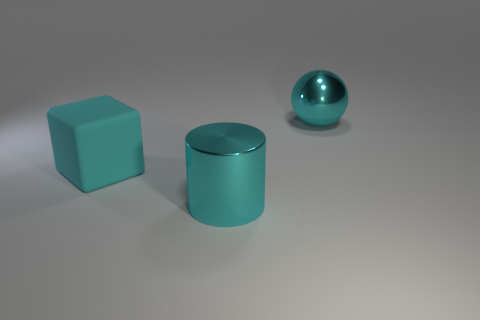Add 3 tiny matte cylinders. How many objects exist? 6 Subtract all cylinders. How many objects are left? 2 Add 3 cyan shiny objects. How many cyan shiny objects exist? 5 Subtract 0 purple spheres. How many objects are left? 3 Subtract all cyan spheres. Subtract all big cylinders. How many objects are left? 1 Add 3 large cyan cubes. How many large cyan cubes are left? 4 